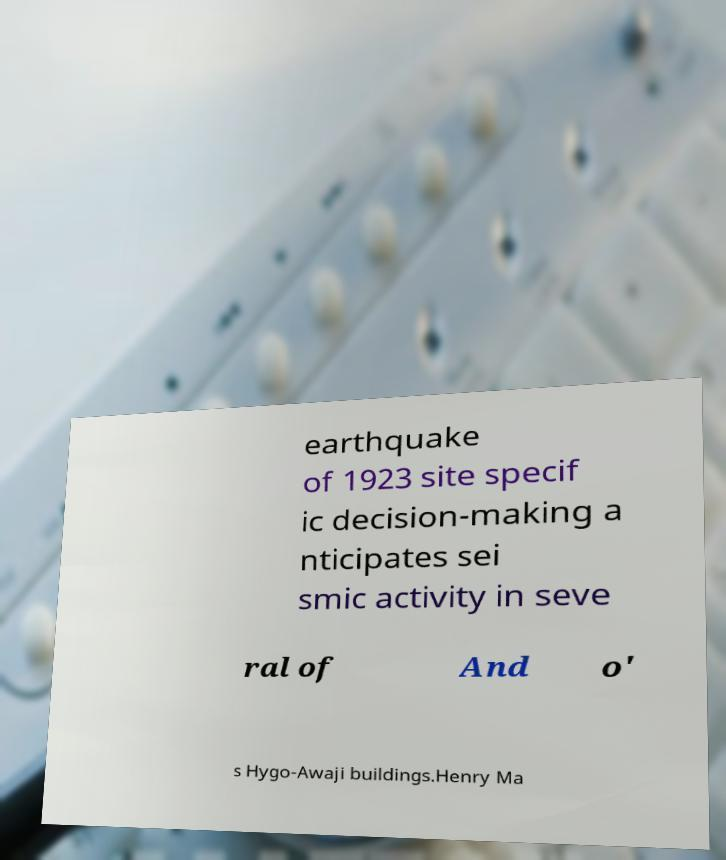Can you accurately transcribe the text from the provided image for me? earthquake of 1923 site specif ic decision-making a nticipates sei smic activity in seve ral of And o' s Hygo-Awaji buildings.Henry Ma 